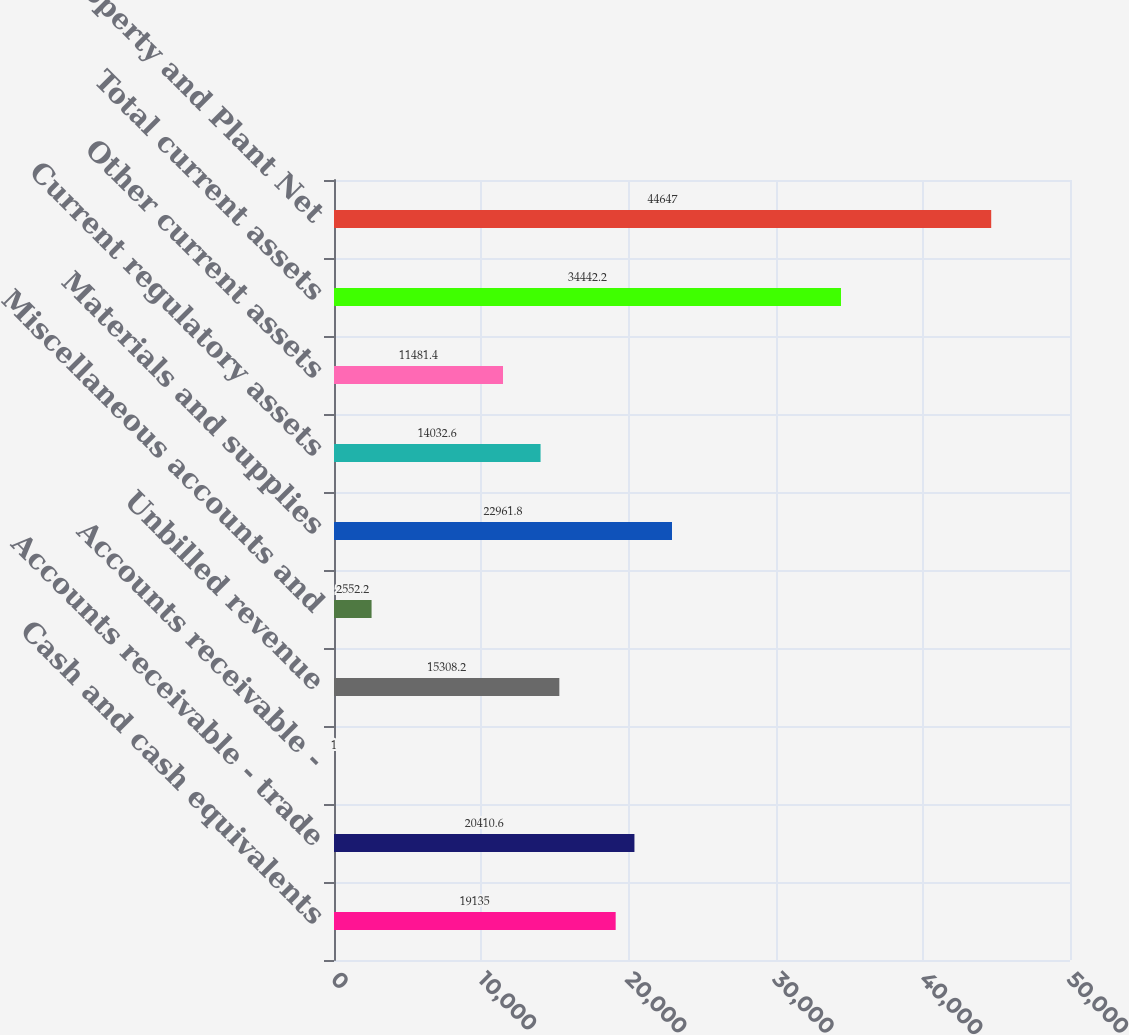<chart> <loc_0><loc_0><loc_500><loc_500><bar_chart><fcel>Cash and cash equivalents<fcel>Accounts receivable - trade<fcel>Accounts receivable -<fcel>Unbilled revenue<fcel>Miscellaneous accounts and<fcel>Materials and supplies<fcel>Current regulatory assets<fcel>Other current assets<fcel>Total current assets<fcel>Property and Plant Net<nl><fcel>19135<fcel>20410.6<fcel>1<fcel>15308.2<fcel>2552.2<fcel>22961.8<fcel>14032.6<fcel>11481.4<fcel>34442.2<fcel>44647<nl></chart> 